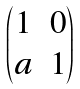Convert formula to latex. <formula><loc_0><loc_0><loc_500><loc_500>\begin{pmatrix} 1 & 0 \\ a & 1 \\ \end{pmatrix}</formula> 